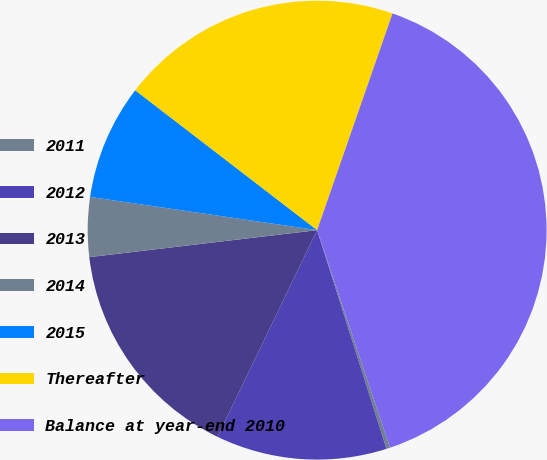Convert chart. <chart><loc_0><loc_0><loc_500><loc_500><pie_chart><fcel>2011<fcel>2012<fcel>2013<fcel>2014<fcel>2015<fcel>Thereafter<fcel>Balance at year-end 2010<nl><fcel>0.26%<fcel>12.04%<fcel>15.97%<fcel>4.19%<fcel>8.12%<fcel>19.9%<fcel>39.53%<nl></chart> 